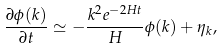<formula> <loc_0><loc_0><loc_500><loc_500>\frac { \partial \phi ( { k } ) } { \partial t } \simeq - \frac { k ^ { 2 } e ^ { - 2 H t } } { H } \phi ( { k } ) + \eta _ { k } ,</formula> 